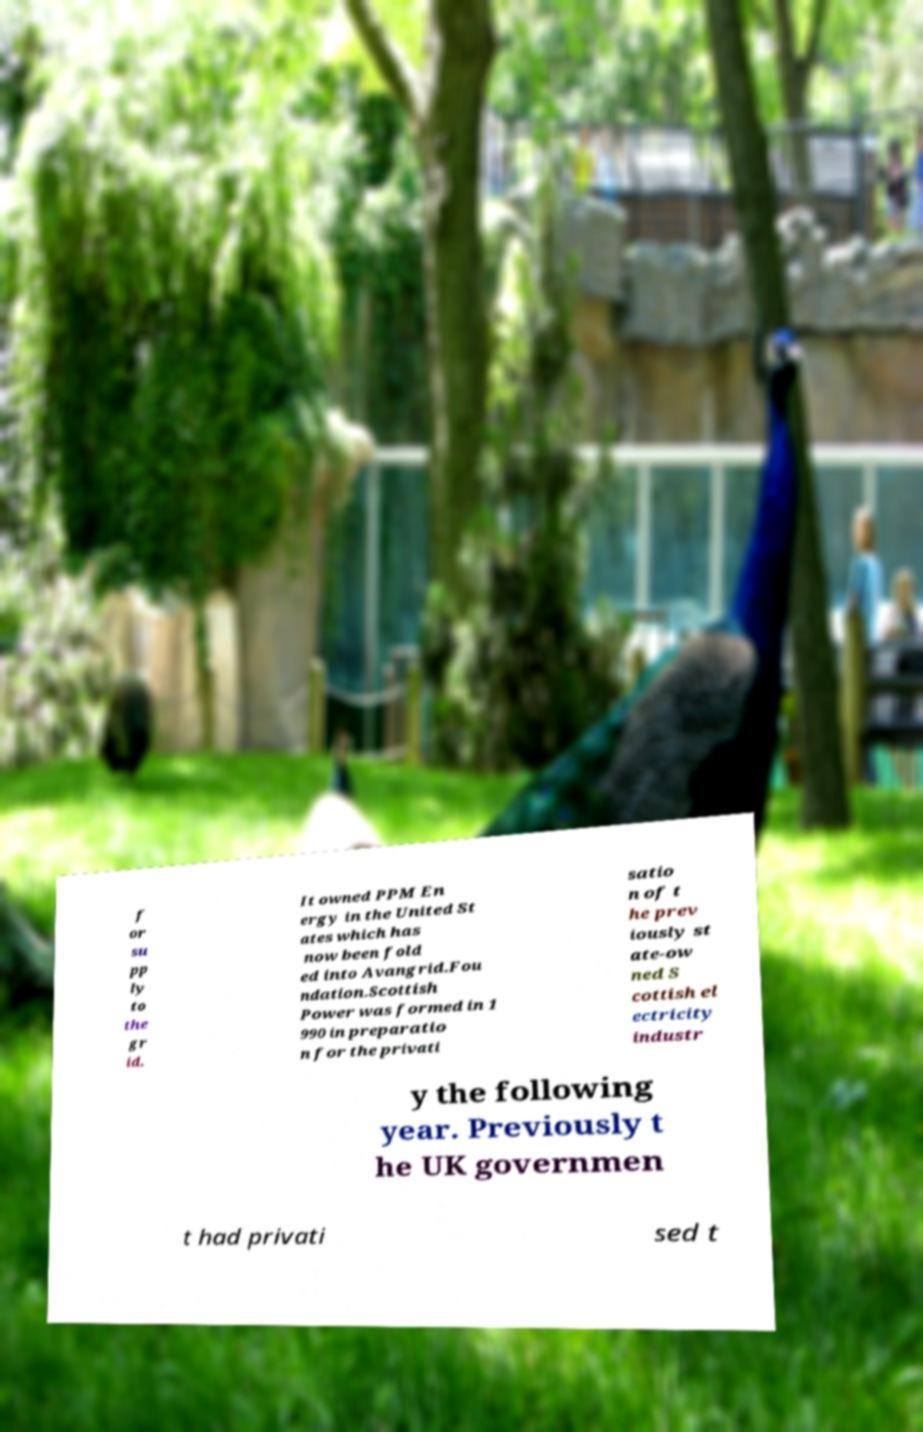I need the written content from this picture converted into text. Can you do that? f or su pp ly to the gr id. It owned PPM En ergy in the United St ates which has now been fold ed into Avangrid.Fou ndation.Scottish Power was formed in 1 990 in preparatio n for the privati satio n of t he prev iously st ate-ow ned S cottish el ectricity industr y the following year. Previously t he UK governmen t had privati sed t 